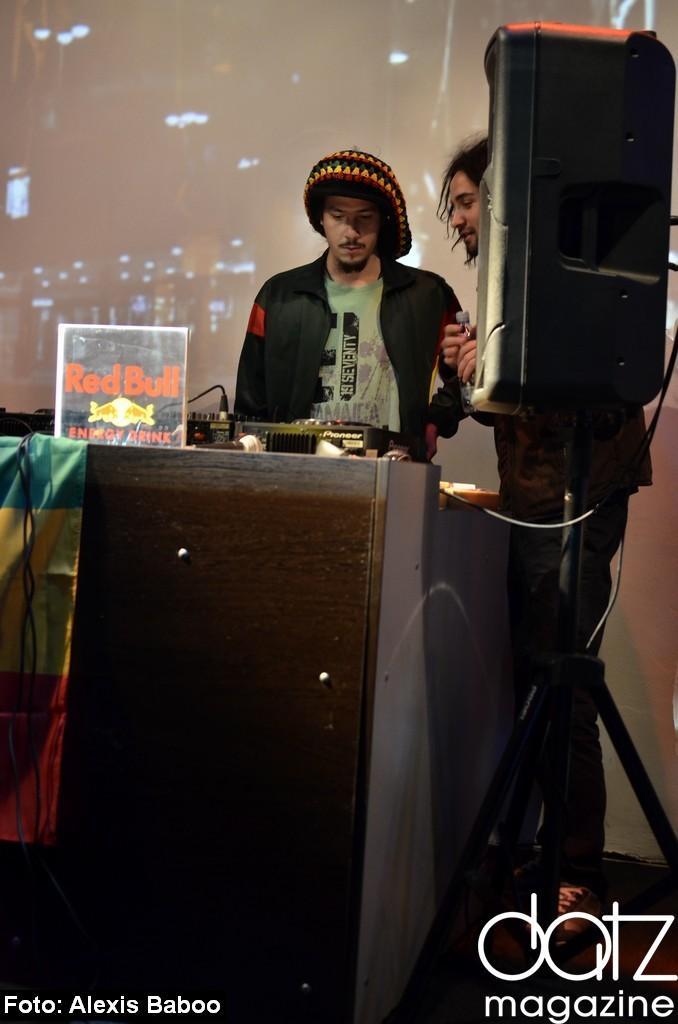Could you give a brief overview of what you see in this image? In this image I can see two persons are standing in front of the table and on the table I can see the musical system and few wires. I can see a black colored speaker and the screen in the background. 